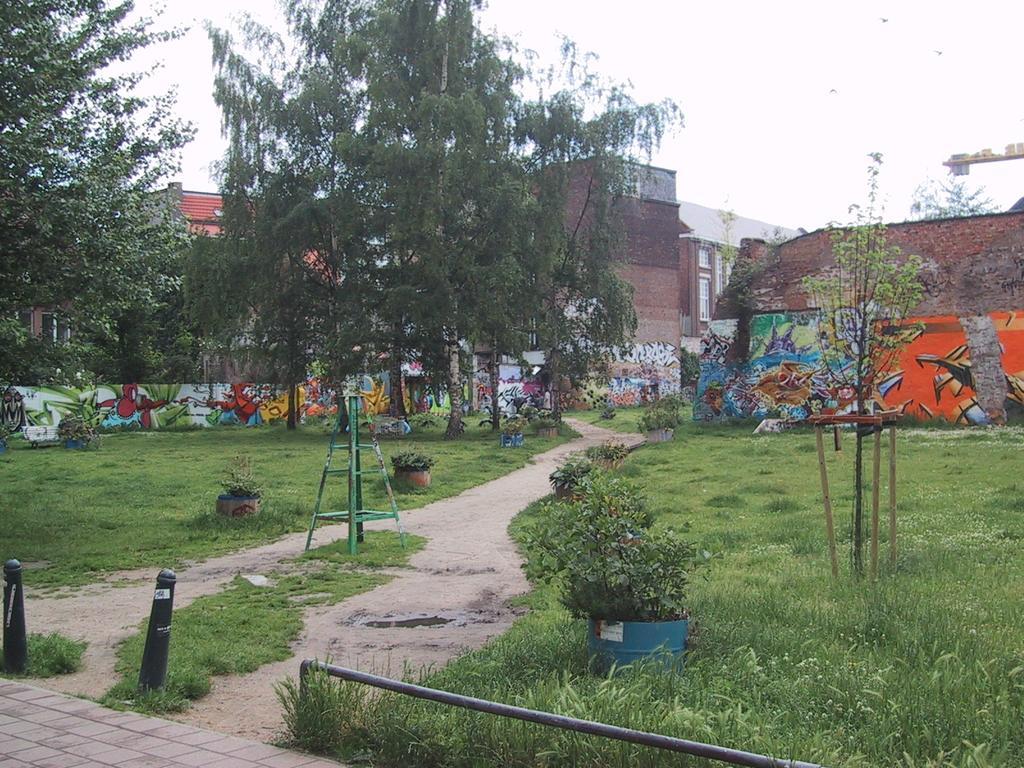How would you summarize this image in a sentence or two? These are trees and buildings, these is grass. 